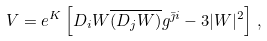Convert formula to latex. <formula><loc_0><loc_0><loc_500><loc_500>V = e ^ { K } \left [ D _ { i } W \overline { ( D _ { j } W ) } g ^ { \bar { \jmath } i } - 3 | W | ^ { 2 } \right ] \, ,</formula> 